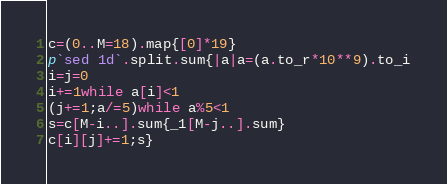<code> <loc_0><loc_0><loc_500><loc_500><_Ruby_>c=(0..M=18).map{[0]*19}
p`sed 1d`.split.sum{|a|a=(a.to_r*10**9).to_i
i=j=0
i+=1while a[i]<1
(j+=1;a/=5)while a%5<1
s=c[M-i..].sum{_1[M-j..].sum}
c[i][j]+=1;s}</code> 